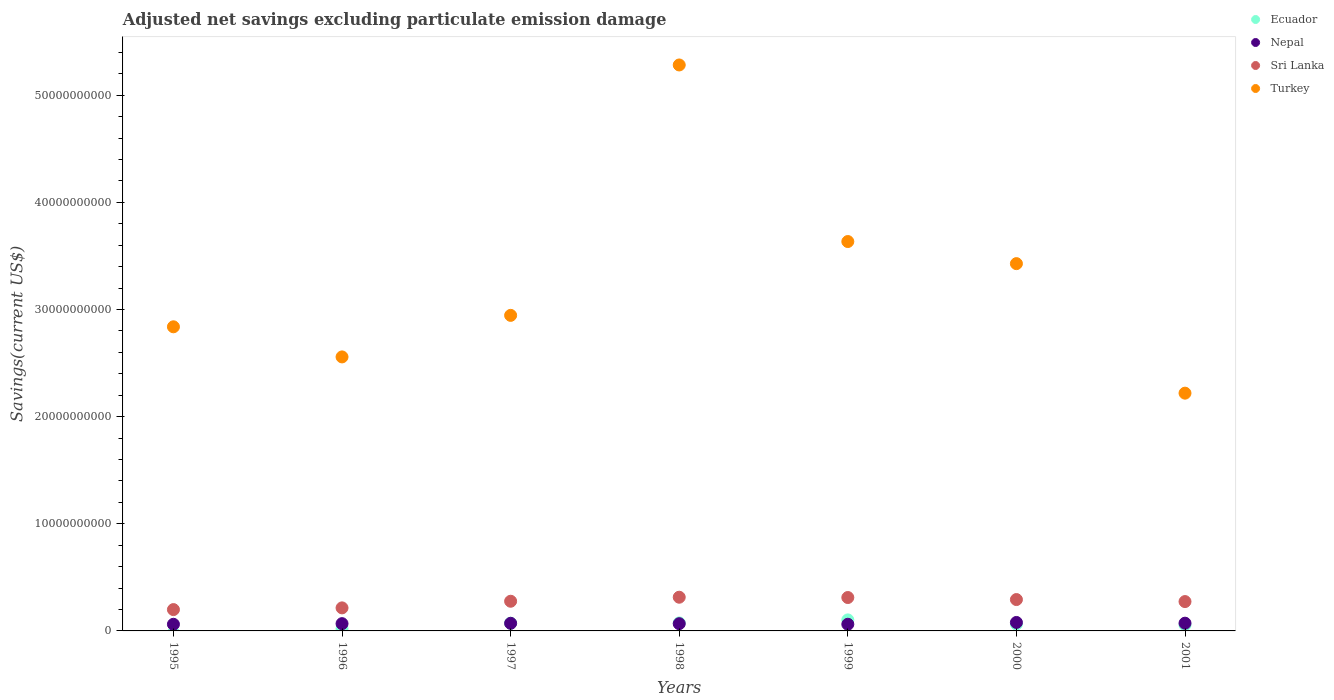How many different coloured dotlines are there?
Offer a terse response. 4. Is the number of dotlines equal to the number of legend labels?
Offer a very short reply. No. What is the adjusted net savings in Turkey in 2001?
Give a very brief answer. 2.22e+1. Across all years, what is the maximum adjusted net savings in Ecuador?
Offer a very short reply. 1.03e+09. What is the total adjusted net savings in Sri Lanka in the graph?
Give a very brief answer. 1.88e+1. What is the difference between the adjusted net savings in Nepal in 2000 and that in 2001?
Your answer should be very brief. 6.73e+07. What is the difference between the adjusted net savings in Nepal in 1997 and the adjusted net savings in Sri Lanka in 1995?
Your answer should be compact. -1.28e+09. What is the average adjusted net savings in Nepal per year?
Offer a very short reply. 6.89e+08. In the year 1996, what is the difference between the adjusted net savings in Turkey and adjusted net savings in Nepal?
Give a very brief answer. 2.49e+1. What is the ratio of the adjusted net savings in Nepal in 2000 to that in 2001?
Keep it short and to the point. 1.09. Is the adjusted net savings in Sri Lanka in 1997 less than that in 1998?
Provide a succinct answer. Yes. Is the difference between the adjusted net savings in Turkey in 1995 and 1997 greater than the difference between the adjusted net savings in Nepal in 1995 and 1997?
Provide a succinct answer. No. What is the difference between the highest and the second highest adjusted net savings in Sri Lanka?
Offer a very short reply. 2.79e+07. What is the difference between the highest and the lowest adjusted net savings in Ecuador?
Give a very brief answer. 1.03e+09. Is it the case that in every year, the sum of the adjusted net savings in Ecuador and adjusted net savings in Turkey  is greater than the sum of adjusted net savings in Sri Lanka and adjusted net savings in Nepal?
Give a very brief answer. Yes. Does the adjusted net savings in Turkey monotonically increase over the years?
Offer a very short reply. No. Is the adjusted net savings in Nepal strictly greater than the adjusted net savings in Turkey over the years?
Your answer should be very brief. No. How many years are there in the graph?
Keep it short and to the point. 7. What is the difference between two consecutive major ticks on the Y-axis?
Keep it short and to the point. 1.00e+1. Are the values on the major ticks of Y-axis written in scientific E-notation?
Your answer should be very brief. No. Does the graph contain any zero values?
Your answer should be very brief. Yes. Does the graph contain grids?
Offer a very short reply. No. What is the title of the graph?
Offer a terse response. Adjusted net savings excluding particulate emission damage. Does "Australia" appear as one of the legend labels in the graph?
Give a very brief answer. No. What is the label or title of the X-axis?
Offer a very short reply. Years. What is the label or title of the Y-axis?
Offer a terse response. Savings(current US$). What is the Savings(current US$) in Ecuador in 1995?
Give a very brief answer. 0. What is the Savings(current US$) in Nepal in 1995?
Provide a short and direct response. 6.20e+08. What is the Savings(current US$) in Sri Lanka in 1995?
Keep it short and to the point. 1.99e+09. What is the Savings(current US$) in Turkey in 1995?
Your answer should be very brief. 2.84e+1. What is the Savings(current US$) in Ecuador in 1996?
Your response must be concise. 1.97e+08. What is the Savings(current US$) of Nepal in 1996?
Offer a very short reply. 6.79e+08. What is the Savings(current US$) in Sri Lanka in 1996?
Your answer should be compact. 2.15e+09. What is the Savings(current US$) of Turkey in 1996?
Offer a very short reply. 2.56e+1. What is the Savings(current US$) in Ecuador in 1997?
Offer a terse response. 7.21e+08. What is the Savings(current US$) of Nepal in 1997?
Your answer should be very brief. 7.10e+08. What is the Savings(current US$) in Sri Lanka in 1997?
Make the answer very short. 2.77e+09. What is the Savings(current US$) in Turkey in 1997?
Your response must be concise. 2.95e+1. What is the Savings(current US$) of Ecuador in 1998?
Make the answer very short. 7.48e+08. What is the Savings(current US$) in Nepal in 1998?
Keep it short and to the point. 6.75e+08. What is the Savings(current US$) in Sri Lanka in 1998?
Offer a very short reply. 3.15e+09. What is the Savings(current US$) of Turkey in 1998?
Your answer should be very brief. 5.28e+1. What is the Savings(current US$) in Ecuador in 1999?
Ensure brevity in your answer.  1.03e+09. What is the Savings(current US$) in Nepal in 1999?
Make the answer very short. 6.23e+08. What is the Savings(current US$) in Sri Lanka in 1999?
Keep it short and to the point. 3.12e+09. What is the Savings(current US$) in Turkey in 1999?
Your answer should be very brief. 3.63e+1. What is the Savings(current US$) in Ecuador in 2000?
Offer a terse response. 6.41e+08. What is the Savings(current US$) of Nepal in 2000?
Keep it short and to the point. 7.90e+08. What is the Savings(current US$) of Sri Lanka in 2000?
Your response must be concise. 2.93e+09. What is the Savings(current US$) in Turkey in 2000?
Provide a succinct answer. 3.43e+1. What is the Savings(current US$) of Ecuador in 2001?
Your answer should be very brief. 5.61e+08. What is the Savings(current US$) of Nepal in 2001?
Offer a very short reply. 7.23e+08. What is the Savings(current US$) of Sri Lanka in 2001?
Make the answer very short. 2.74e+09. What is the Savings(current US$) of Turkey in 2001?
Provide a short and direct response. 2.22e+1. Across all years, what is the maximum Savings(current US$) in Ecuador?
Keep it short and to the point. 1.03e+09. Across all years, what is the maximum Savings(current US$) in Nepal?
Your answer should be compact. 7.90e+08. Across all years, what is the maximum Savings(current US$) of Sri Lanka?
Offer a very short reply. 3.15e+09. Across all years, what is the maximum Savings(current US$) in Turkey?
Provide a short and direct response. 5.28e+1. Across all years, what is the minimum Savings(current US$) in Nepal?
Keep it short and to the point. 6.20e+08. Across all years, what is the minimum Savings(current US$) in Sri Lanka?
Offer a very short reply. 1.99e+09. Across all years, what is the minimum Savings(current US$) of Turkey?
Your response must be concise. 2.22e+1. What is the total Savings(current US$) of Ecuador in the graph?
Offer a very short reply. 3.90e+09. What is the total Savings(current US$) of Nepal in the graph?
Provide a short and direct response. 4.82e+09. What is the total Savings(current US$) in Sri Lanka in the graph?
Provide a short and direct response. 1.88e+1. What is the total Savings(current US$) in Turkey in the graph?
Provide a short and direct response. 2.29e+11. What is the difference between the Savings(current US$) of Nepal in 1995 and that in 1996?
Offer a very short reply. -5.89e+07. What is the difference between the Savings(current US$) in Sri Lanka in 1995 and that in 1996?
Your response must be concise. -1.60e+08. What is the difference between the Savings(current US$) of Turkey in 1995 and that in 1996?
Provide a short and direct response. 2.81e+09. What is the difference between the Savings(current US$) in Nepal in 1995 and that in 1997?
Provide a succinct answer. -9.05e+07. What is the difference between the Savings(current US$) of Sri Lanka in 1995 and that in 1997?
Ensure brevity in your answer.  -7.79e+08. What is the difference between the Savings(current US$) of Turkey in 1995 and that in 1997?
Provide a succinct answer. -1.07e+09. What is the difference between the Savings(current US$) of Nepal in 1995 and that in 1998?
Provide a short and direct response. -5.53e+07. What is the difference between the Savings(current US$) of Sri Lanka in 1995 and that in 1998?
Your response must be concise. -1.15e+09. What is the difference between the Savings(current US$) in Turkey in 1995 and that in 1998?
Give a very brief answer. -2.44e+1. What is the difference between the Savings(current US$) in Nepal in 1995 and that in 1999?
Your answer should be very brief. -2.57e+06. What is the difference between the Savings(current US$) in Sri Lanka in 1995 and that in 1999?
Your answer should be compact. -1.13e+09. What is the difference between the Savings(current US$) in Turkey in 1995 and that in 1999?
Ensure brevity in your answer.  -7.96e+09. What is the difference between the Savings(current US$) in Nepal in 1995 and that in 2000?
Keep it short and to the point. -1.70e+08. What is the difference between the Savings(current US$) in Sri Lanka in 1995 and that in 2000?
Provide a succinct answer. -9.37e+08. What is the difference between the Savings(current US$) in Turkey in 1995 and that in 2000?
Offer a very short reply. -5.90e+09. What is the difference between the Savings(current US$) of Nepal in 1995 and that in 2001?
Provide a succinct answer. -1.03e+08. What is the difference between the Savings(current US$) in Sri Lanka in 1995 and that in 2001?
Your answer should be compact. -7.48e+08. What is the difference between the Savings(current US$) of Turkey in 1995 and that in 2001?
Make the answer very short. 6.19e+09. What is the difference between the Savings(current US$) in Ecuador in 1996 and that in 1997?
Your answer should be very brief. -5.25e+08. What is the difference between the Savings(current US$) in Nepal in 1996 and that in 1997?
Offer a terse response. -3.16e+07. What is the difference between the Savings(current US$) in Sri Lanka in 1996 and that in 1997?
Your answer should be very brief. -6.20e+08. What is the difference between the Savings(current US$) in Turkey in 1996 and that in 1997?
Your response must be concise. -3.88e+09. What is the difference between the Savings(current US$) in Ecuador in 1996 and that in 1998?
Your answer should be compact. -5.52e+08. What is the difference between the Savings(current US$) of Nepal in 1996 and that in 1998?
Offer a very short reply. 3.65e+06. What is the difference between the Savings(current US$) in Sri Lanka in 1996 and that in 1998?
Offer a terse response. -9.95e+08. What is the difference between the Savings(current US$) in Turkey in 1996 and that in 1998?
Your answer should be compact. -2.73e+1. What is the difference between the Savings(current US$) of Ecuador in 1996 and that in 1999?
Make the answer very short. -8.33e+08. What is the difference between the Savings(current US$) in Nepal in 1996 and that in 1999?
Ensure brevity in your answer.  5.64e+07. What is the difference between the Savings(current US$) in Sri Lanka in 1996 and that in 1999?
Ensure brevity in your answer.  -9.67e+08. What is the difference between the Savings(current US$) in Turkey in 1996 and that in 1999?
Provide a short and direct response. -1.08e+1. What is the difference between the Savings(current US$) of Ecuador in 1996 and that in 2000?
Offer a very short reply. -4.45e+08. What is the difference between the Savings(current US$) in Nepal in 1996 and that in 2000?
Ensure brevity in your answer.  -1.11e+08. What is the difference between the Savings(current US$) of Sri Lanka in 1996 and that in 2000?
Offer a terse response. -7.77e+08. What is the difference between the Savings(current US$) of Turkey in 1996 and that in 2000?
Your response must be concise. -8.71e+09. What is the difference between the Savings(current US$) in Ecuador in 1996 and that in 2001?
Offer a very short reply. -3.65e+08. What is the difference between the Savings(current US$) of Nepal in 1996 and that in 2001?
Make the answer very short. -4.42e+07. What is the difference between the Savings(current US$) of Sri Lanka in 1996 and that in 2001?
Make the answer very short. -5.89e+08. What is the difference between the Savings(current US$) in Turkey in 1996 and that in 2001?
Provide a succinct answer. 3.38e+09. What is the difference between the Savings(current US$) in Ecuador in 1997 and that in 1998?
Ensure brevity in your answer.  -2.72e+07. What is the difference between the Savings(current US$) in Nepal in 1997 and that in 1998?
Provide a short and direct response. 3.52e+07. What is the difference between the Savings(current US$) in Sri Lanka in 1997 and that in 1998?
Your answer should be compact. -3.75e+08. What is the difference between the Savings(current US$) in Turkey in 1997 and that in 1998?
Your response must be concise. -2.34e+1. What is the difference between the Savings(current US$) in Ecuador in 1997 and that in 1999?
Your answer should be very brief. -3.08e+08. What is the difference between the Savings(current US$) of Nepal in 1997 and that in 1999?
Your answer should be very brief. 8.79e+07. What is the difference between the Savings(current US$) in Sri Lanka in 1997 and that in 1999?
Provide a short and direct response. -3.47e+08. What is the difference between the Savings(current US$) in Turkey in 1997 and that in 1999?
Your answer should be very brief. -6.89e+09. What is the difference between the Savings(current US$) of Ecuador in 1997 and that in 2000?
Offer a terse response. 7.98e+07. What is the difference between the Savings(current US$) in Nepal in 1997 and that in 2000?
Offer a very short reply. -7.99e+07. What is the difference between the Savings(current US$) in Sri Lanka in 1997 and that in 2000?
Offer a terse response. -1.57e+08. What is the difference between the Savings(current US$) of Turkey in 1997 and that in 2000?
Provide a short and direct response. -4.83e+09. What is the difference between the Savings(current US$) in Ecuador in 1997 and that in 2001?
Your response must be concise. 1.60e+08. What is the difference between the Savings(current US$) in Nepal in 1997 and that in 2001?
Offer a terse response. -1.26e+07. What is the difference between the Savings(current US$) of Sri Lanka in 1997 and that in 2001?
Make the answer very short. 3.12e+07. What is the difference between the Savings(current US$) in Turkey in 1997 and that in 2001?
Keep it short and to the point. 7.26e+09. What is the difference between the Savings(current US$) of Ecuador in 1998 and that in 1999?
Provide a succinct answer. -2.81e+08. What is the difference between the Savings(current US$) in Nepal in 1998 and that in 1999?
Your answer should be very brief. 5.27e+07. What is the difference between the Savings(current US$) in Sri Lanka in 1998 and that in 1999?
Give a very brief answer. 2.79e+07. What is the difference between the Savings(current US$) of Turkey in 1998 and that in 1999?
Your response must be concise. 1.65e+1. What is the difference between the Savings(current US$) in Ecuador in 1998 and that in 2000?
Provide a succinct answer. 1.07e+08. What is the difference between the Savings(current US$) of Nepal in 1998 and that in 2000?
Offer a terse response. -1.15e+08. What is the difference between the Savings(current US$) in Sri Lanka in 1998 and that in 2000?
Ensure brevity in your answer.  2.18e+08. What is the difference between the Savings(current US$) in Turkey in 1998 and that in 2000?
Your answer should be compact. 1.85e+1. What is the difference between the Savings(current US$) in Ecuador in 1998 and that in 2001?
Offer a very short reply. 1.87e+08. What is the difference between the Savings(current US$) of Nepal in 1998 and that in 2001?
Provide a succinct answer. -4.78e+07. What is the difference between the Savings(current US$) in Sri Lanka in 1998 and that in 2001?
Provide a short and direct response. 4.06e+08. What is the difference between the Savings(current US$) of Turkey in 1998 and that in 2001?
Give a very brief answer. 3.06e+1. What is the difference between the Savings(current US$) of Ecuador in 1999 and that in 2000?
Make the answer very short. 3.88e+08. What is the difference between the Savings(current US$) of Nepal in 1999 and that in 2000?
Keep it short and to the point. -1.68e+08. What is the difference between the Savings(current US$) of Sri Lanka in 1999 and that in 2000?
Your response must be concise. 1.90e+08. What is the difference between the Savings(current US$) in Turkey in 1999 and that in 2000?
Offer a very short reply. 2.06e+09. What is the difference between the Savings(current US$) in Ecuador in 1999 and that in 2001?
Provide a short and direct response. 4.68e+08. What is the difference between the Savings(current US$) in Nepal in 1999 and that in 2001?
Your answer should be compact. -1.01e+08. What is the difference between the Savings(current US$) in Sri Lanka in 1999 and that in 2001?
Offer a very short reply. 3.78e+08. What is the difference between the Savings(current US$) in Turkey in 1999 and that in 2001?
Ensure brevity in your answer.  1.42e+1. What is the difference between the Savings(current US$) of Ecuador in 2000 and that in 2001?
Keep it short and to the point. 8.04e+07. What is the difference between the Savings(current US$) of Nepal in 2000 and that in 2001?
Keep it short and to the point. 6.73e+07. What is the difference between the Savings(current US$) of Sri Lanka in 2000 and that in 2001?
Offer a very short reply. 1.88e+08. What is the difference between the Savings(current US$) of Turkey in 2000 and that in 2001?
Provide a succinct answer. 1.21e+1. What is the difference between the Savings(current US$) in Nepal in 1995 and the Savings(current US$) in Sri Lanka in 1996?
Your response must be concise. -1.53e+09. What is the difference between the Savings(current US$) of Nepal in 1995 and the Savings(current US$) of Turkey in 1996?
Ensure brevity in your answer.  -2.50e+1. What is the difference between the Savings(current US$) in Sri Lanka in 1995 and the Savings(current US$) in Turkey in 1996?
Your answer should be compact. -2.36e+1. What is the difference between the Savings(current US$) of Nepal in 1995 and the Savings(current US$) of Sri Lanka in 1997?
Provide a short and direct response. -2.15e+09. What is the difference between the Savings(current US$) of Nepal in 1995 and the Savings(current US$) of Turkey in 1997?
Offer a terse response. -2.88e+1. What is the difference between the Savings(current US$) of Sri Lanka in 1995 and the Savings(current US$) of Turkey in 1997?
Make the answer very short. -2.75e+1. What is the difference between the Savings(current US$) in Nepal in 1995 and the Savings(current US$) in Sri Lanka in 1998?
Provide a succinct answer. -2.53e+09. What is the difference between the Savings(current US$) in Nepal in 1995 and the Savings(current US$) in Turkey in 1998?
Your answer should be very brief. -5.22e+1. What is the difference between the Savings(current US$) of Sri Lanka in 1995 and the Savings(current US$) of Turkey in 1998?
Make the answer very short. -5.08e+1. What is the difference between the Savings(current US$) of Nepal in 1995 and the Savings(current US$) of Sri Lanka in 1999?
Your response must be concise. -2.50e+09. What is the difference between the Savings(current US$) of Nepal in 1995 and the Savings(current US$) of Turkey in 1999?
Provide a succinct answer. -3.57e+1. What is the difference between the Savings(current US$) of Sri Lanka in 1995 and the Savings(current US$) of Turkey in 1999?
Provide a succinct answer. -3.44e+1. What is the difference between the Savings(current US$) in Nepal in 1995 and the Savings(current US$) in Sri Lanka in 2000?
Your answer should be very brief. -2.31e+09. What is the difference between the Savings(current US$) of Nepal in 1995 and the Savings(current US$) of Turkey in 2000?
Provide a short and direct response. -3.37e+1. What is the difference between the Savings(current US$) of Sri Lanka in 1995 and the Savings(current US$) of Turkey in 2000?
Offer a terse response. -3.23e+1. What is the difference between the Savings(current US$) in Nepal in 1995 and the Savings(current US$) in Sri Lanka in 2001?
Provide a short and direct response. -2.12e+09. What is the difference between the Savings(current US$) of Nepal in 1995 and the Savings(current US$) of Turkey in 2001?
Ensure brevity in your answer.  -2.16e+1. What is the difference between the Savings(current US$) in Sri Lanka in 1995 and the Savings(current US$) in Turkey in 2001?
Provide a succinct answer. -2.02e+1. What is the difference between the Savings(current US$) in Ecuador in 1996 and the Savings(current US$) in Nepal in 1997?
Make the answer very short. -5.14e+08. What is the difference between the Savings(current US$) of Ecuador in 1996 and the Savings(current US$) of Sri Lanka in 1997?
Make the answer very short. -2.57e+09. What is the difference between the Savings(current US$) of Ecuador in 1996 and the Savings(current US$) of Turkey in 1997?
Offer a very short reply. -2.93e+1. What is the difference between the Savings(current US$) of Nepal in 1996 and the Savings(current US$) of Sri Lanka in 1997?
Make the answer very short. -2.09e+09. What is the difference between the Savings(current US$) of Nepal in 1996 and the Savings(current US$) of Turkey in 1997?
Your response must be concise. -2.88e+1. What is the difference between the Savings(current US$) in Sri Lanka in 1996 and the Savings(current US$) in Turkey in 1997?
Give a very brief answer. -2.73e+1. What is the difference between the Savings(current US$) in Ecuador in 1996 and the Savings(current US$) in Nepal in 1998?
Provide a succinct answer. -4.79e+08. What is the difference between the Savings(current US$) of Ecuador in 1996 and the Savings(current US$) of Sri Lanka in 1998?
Make the answer very short. -2.95e+09. What is the difference between the Savings(current US$) in Ecuador in 1996 and the Savings(current US$) in Turkey in 1998?
Provide a succinct answer. -5.26e+1. What is the difference between the Savings(current US$) of Nepal in 1996 and the Savings(current US$) of Sri Lanka in 1998?
Provide a short and direct response. -2.47e+09. What is the difference between the Savings(current US$) in Nepal in 1996 and the Savings(current US$) in Turkey in 1998?
Give a very brief answer. -5.21e+1. What is the difference between the Savings(current US$) in Sri Lanka in 1996 and the Savings(current US$) in Turkey in 1998?
Give a very brief answer. -5.07e+1. What is the difference between the Savings(current US$) of Ecuador in 1996 and the Savings(current US$) of Nepal in 1999?
Offer a very short reply. -4.26e+08. What is the difference between the Savings(current US$) in Ecuador in 1996 and the Savings(current US$) in Sri Lanka in 1999?
Your answer should be very brief. -2.92e+09. What is the difference between the Savings(current US$) of Ecuador in 1996 and the Savings(current US$) of Turkey in 1999?
Provide a succinct answer. -3.61e+1. What is the difference between the Savings(current US$) in Nepal in 1996 and the Savings(current US$) in Sri Lanka in 1999?
Give a very brief answer. -2.44e+09. What is the difference between the Savings(current US$) of Nepal in 1996 and the Savings(current US$) of Turkey in 1999?
Keep it short and to the point. -3.57e+1. What is the difference between the Savings(current US$) in Sri Lanka in 1996 and the Savings(current US$) in Turkey in 1999?
Offer a terse response. -3.42e+1. What is the difference between the Savings(current US$) in Ecuador in 1996 and the Savings(current US$) in Nepal in 2000?
Keep it short and to the point. -5.94e+08. What is the difference between the Savings(current US$) in Ecuador in 1996 and the Savings(current US$) in Sri Lanka in 2000?
Provide a succinct answer. -2.73e+09. What is the difference between the Savings(current US$) of Ecuador in 1996 and the Savings(current US$) of Turkey in 2000?
Your answer should be compact. -3.41e+1. What is the difference between the Savings(current US$) of Nepal in 1996 and the Savings(current US$) of Sri Lanka in 2000?
Your response must be concise. -2.25e+09. What is the difference between the Savings(current US$) in Nepal in 1996 and the Savings(current US$) in Turkey in 2000?
Offer a very short reply. -3.36e+1. What is the difference between the Savings(current US$) in Sri Lanka in 1996 and the Savings(current US$) in Turkey in 2000?
Ensure brevity in your answer.  -3.21e+1. What is the difference between the Savings(current US$) of Ecuador in 1996 and the Savings(current US$) of Nepal in 2001?
Provide a short and direct response. -5.27e+08. What is the difference between the Savings(current US$) of Ecuador in 1996 and the Savings(current US$) of Sri Lanka in 2001?
Provide a short and direct response. -2.54e+09. What is the difference between the Savings(current US$) of Ecuador in 1996 and the Savings(current US$) of Turkey in 2001?
Provide a short and direct response. -2.20e+1. What is the difference between the Savings(current US$) in Nepal in 1996 and the Savings(current US$) in Sri Lanka in 2001?
Keep it short and to the point. -2.06e+09. What is the difference between the Savings(current US$) of Nepal in 1996 and the Savings(current US$) of Turkey in 2001?
Your response must be concise. -2.15e+1. What is the difference between the Savings(current US$) in Sri Lanka in 1996 and the Savings(current US$) in Turkey in 2001?
Provide a succinct answer. -2.00e+1. What is the difference between the Savings(current US$) of Ecuador in 1997 and the Savings(current US$) of Nepal in 1998?
Your answer should be compact. 4.60e+07. What is the difference between the Savings(current US$) in Ecuador in 1997 and the Savings(current US$) in Sri Lanka in 1998?
Your answer should be compact. -2.42e+09. What is the difference between the Savings(current US$) of Ecuador in 1997 and the Savings(current US$) of Turkey in 1998?
Provide a short and direct response. -5.21e+1. What is the difference between the Savings(current US$) of Nepal in 1997 and the Savings(current US$) of Sri Lanka in 1998?
Keep it short and to the point. -2.44e+09. What is the difference between the Savings(current US$) in Nepal in 1997 and the Savings(current US$) in Turkey in 1998?
Give a very brief answer. -5.21e+1. What is the difference between the Savings(current US$) in Sri Lanka in 1997 and the Savings(current US$) in Turkey in 1998?
Your answer should be compact. -5.01e+1. What is the difference between the Savings(current US$) of Ecuador in 1997 and the Savings(current US$) of Nepal in 1999?
Keep it short and to the point. 9.87e+07. What is the difference between the Savings(current US$) in Ecuador in 1997 and the Savings(current US$) in Sri Lanka in 1999?
Offer a very short reply. -2.40e+09. What is the difference between the Savings(current US$) in Ecuador in 1997 and the Savings(current US$) in Turkey in 1999?
Offer a terse response. -3.56e+1. What is the difference between the Savings(current US$) in Nepal in 1997 and the Savings(current US$) in Sri Lanka in 1999?
Offer a very short reply. -2.41e+09. What is the difference between the Savings(current US$) in Nepal in 1997 and the Savings(current US$) in Turkey in 1999?
Offer a terse response. -3.56e+1. What is the difference between the Savings(current US$) in Sri Lanka in 1997 and the Savings(current US$) in Turkey in 1999?
Your answer should be compact. -3.36e+1. What is the difference between the Savings(current US$) of Ecuador in 1997 and the Savings(current US$) of Nepal in 2000?
Your answer should be compact. -6.91e+07. What is the difference between the Savings(current US$) of Ecuador in 1997 and the Savings(current US$) of Sri Lanka in 2000?
Offer a terse response. -2.21e+09. What is the difference between the Savings(current US$) of Ecuador in 1997 and the Savings(current US$) of Turkey in 2000?
Provide a succinct answer. -3.36e+1. What is the difference between the Savings(current US$) in Nepal in 1997 and the Savings(current US$) in Sri Lanka in 2000?
Ensure brevity in your answer.  -2.22e+09. What is the difference between the Savings(current US$) in Nepal in 1997 and the Savings(current US$) in Turkey in 2000?
Give a very brief answer. -3.36e+1. What is the difference between the Savings(current US$) of Sri Lanka in 1997 and the Savings(current US$) of Turkey in 2000?
Your response must be concise. -3.15e+1. What is the difference between the Savings(current US$) of Ecuador in 1997 and the Savings(current US$) of Nepal in 2001?
Your answer should be very brief. -1.79e+06. What is the difference between the Savings(current US$) in Ecuador in 1997 and the Savings(current US$) in Sri Lanka in 2001?
Provide a succinct answer. -2.02e+09. What is the difference between the Savings(current US$) in Ecuador in 1997 and the Savings(current US$) in Turkey in 2001?
Offer a very short reply. -2.15e+1. What is the difference between the Savings(current US$) of Nepal in 1997 and the Savings(current US$) of Sri Lanka in 2001?
Make the answer very short. -2.03e+09. What is the difference between the Savings(current US$) of Nepal in 1997 and the Savings(current US$) of Turkey in 2001?
Provide a short and direct response. -2.15e+1. What is the difference between the Savings(current US$) in Sri Lanka in 1997 and the Savings(current US$) in Turkey in 2001?
Provide a succinct answer. -1.94e+1. What is the difference between the Savings(current US$) in Ecuador in 1998 and the Savings(current US$) in Nepal in 1999?
Make the answer very short. 1.26e+08. What is the difference between the Savings(current US$) in Ecuador in 1998 and the Savings(current US$) in Sri Lanka in 1999?
Give a very brief answer. -2.37e+09. What is the difference between the Savings(current US$) of Ecuador in 1998 and the Savings(current US$) of Turkey in 1999?
Provide a succinct answer. -3.56e+1. What is the difference between the Savings(current US$) in Nepal in 1998 and the Savings(current US$) in Sri Lanka in 1999?
Provide a succinct answer. -2.44e+09. What is the difference between the Savings(current US$) of Nepal in 1998 and the Savings(current US$) of Turkey in 1999?
Offer a terse response. -3.57e+1. What is the difference between the Savings(current US$) in Sri Lanka in 1998 and the Savings(current US$) in Turkey in 1999?
Make the answer very short. -3.32e+1. What is the difference between the Savings(current US$) of Ecuador in 1998 and the Savings(current US$) of Nepal in 2000?
Offer a terse response. -4.19e+07. What is the difference between the Savings(current US$) of Ecuador in 1998 and the Savings(current US$) of Sri Lanka in 2000?
Provide a short and direct response. -2.18e+09. What is the difference between the Savings(current US$) in Ecuador in 1998 and the Savings(current US$) in Turkey in 2000?
Keep it short and to the point. -3.35e+1. What is the difference between the Savings(current US$) of Nepal in 1998 and the Savings(current US$) of Sri Lanka in 2000?
Your response must be concise. -2.25e+09. What is the difference between the Savings(current US$) in Nepal in 1998 and the Savings(current US$) in Turkey in 2000?
Your answer should be compact. -3.36e+1. What is the difference between the Savings(current US$) in Sri Lanka in 1998 and the Savings(current US$) in Turkey in 2000?
Your answer should be compact. -3.11e+1. What is the difference between the Savings(current US$) of Ecuador in 1998 and the Savings(current US$) of Nepal in 2001?
Ensure brevity in your answer.  2.54e+07. What is the difference between the Savings(current US$) of Ecuador in 1998 and the Savings(current US$) of Sri Lanka in 2001?
Give a very brief answer. -1.99e+09. What is the difference between the Savings(current US$) in Ecuador in 1998 and the Savings(current US$) in Turkey in 2001?
Your answer should be compact. -2.14e+1. What is the difference between the Savings(current US$) of Nepal in 1998 and the Savings(current US$) of Sri Lanka in 2001?
Provide a short and direct response. -2.06e+09. What is the difference between the Savings(current US$) of Nepal in 1998 and the Savings(current US$) of Turkey in 2001?
Your response must be concise. -2.15e+1. What is the difference between the Savings(current US$) in Sri Lanka in 1998 and the Savings(current US$) in Turkey in 2001?
Your answer should be very brief. -1.90e+1. What is the difference between the Savings(current US$) of Ecuador in 1999 and the Savings(current US$) of Nepal in 2000?
Your response must be concise. 2.39e+08. What is the difference between the Savings(current US$) of Ecuador in 1999 and the Savings(current US$) of Sri Lanka in 2000?
Your answer should be very brief. -1.90e+09. What is the difference between the Savings(current US$) in Ecuador in 1999 and the Savings(current US$) in Turkey in 2000?
Your answer should be very brief. -3.33e+1. What is the difference between the Savings(current US$) in Nepal in 1999 and the Savings(current US$) in Sri Lanka in 2000?
Make the answer very short. -2.31e+09. What is the difference between the Savings(current US$) in Nepal in 1999 and the Savings(current US$) in Turkey in 2000?
Give a very brief answer. -3.37e+1. What is the difference between the Savings(current US$) in Sri Lanka in 1999 and the Savings(current US$) in Turkey in 2000?
Your response must be concise. -3.12e+1. What is the difference between the Savings(current US$) of Ecuador in 1999 and the Savings(current US$) of Nepal in 2001?
Make the answer very short. 3.06e+08. What is the difference between the Savings(current US$) in Ecuador in 1999 and the Savings(current US$) in Sri Lanka in 2001?
Your response must be concise. -1.71e+09. What is the difference between the Savings(current US$) of Ecuador in 1999 and the Savings(current US$) of Turkey in 2001?
Keep it short and to the point. -2.12e+1. What is the difference between the Savings(current US$) in Nepal in 1999 and the Savings(current US$) in Sri Lanka in 2001?
Provide a short and direct response. -2.12e+09. What is the difference between the Savings(current US$) in Nepal in 1999 and the Savings(current US$) in Turkey in 2001?
Give a very brief answer. -2.16e+1. What is the difference between the Savings(current US$) of Sri Lanka in 1999 and the Savings(current US$) of Turkey in 2001?
Give a very brief answer. -1.91e+1. What is the difference between the Savings(current US$) in Ecuador in 2000 and the Savings(current US$) in Nepal in 2001?
Provide a succinct answer. -8.16e+07. What is the difference between the Savings(current US$) in Ecuador in 2000 and the Savings(current US$) in Sri Lanka in 2001?
Your response must be concise. -2.10e+09. What is the difference between the Savings(current US$) in Ecuador in 2000 and the Savings(current US$) in Turkey in 2001?
Your answer should be very brief. -2.16e+1. What is the difference between the Savings(current US$) of Nepal in 2000 and the Savings(current US$) of Sri Lanka in 2001?
Offer a terse response. -1.95e+09. What is the difference between the Savings(current US$) in Nepal in 2000 and the Savings(current US$) in Turkey in 2001?
Give a very brief answer. -2.14e+1. What is the difference between the Savings(current US$) of Sri Lanka in 2000 and the Savings(current US$) of Turkey in 2001?
Give a very brief answer. -1.93e+1. What is the average Savings(current US$) of Ecuador per year?
Give a very brief answer. 5.57e+08. What is the average Savings(current US$) in Nepal per year?
Give a very brief answer. 6.89e+08. What is the average Savings(current US$) in Sri Lanka per year?
Keep it short and to the point. 2.69e+09. What is the average Savings(current US$) in Turkey per year?
Give a very brief answer. 3.27e+1. In the year 1995, what is the difference between the Savings(current US$) in Nepal and Savings(current US$) in Sri Lanka?
Provide a succinct answer. -1.37e+09. In the year 1995, what is the difference between the Savings(current US$) in Nepal and Savings(current US$) in Turkey?
Your response must be concise. -2.78e+1. In the year 1995, what is the difference between the Savings(current US$) in Sri Lanka and Savings(current US$) in Turkey?
Ensure brevity in your answer.  -2.64e+1. In the year 1996, what is the difference between the Savings(current US$) of Ecuador and Savings(current US$) of Nepal?
Ensure brevity in your answer.  -4.82e+08. In the year 1996, what is the difference between the Savings(current US$) in Ecuador and Savings(current US$) in Sri Lanka?
Provide a short and direct response. -1.95e+09. In the year 1996, what is the difference between the Savings(current US$) in Ecuador and Savings(current US$) in Turkey?
Make the answer very short. -2.54e+1. In the year 1996, what is the difference between the Savings(current US$) in Nepal and Savings(current US$) in Sri Lanka?
Offer a terse response. -1.47e+09. In the year 1996, what is the difference between the Savings(current US$) of Nepal and Savings(current US$) of Turkey?
Offer a very short reply. -2.49e+1. In the year 1996, what is the difference between the Savings(current US$) in Sri Lanka and Savings(current US$) in Turkey?
Provide a short and direct response. -2.34e+1. In the year 1997, what is the difference between the Savings(current US$) in Ecuador and Savings(current US$) in Nepal?
Your response must be concise. 1.08e+07. In the year 1997, what is the difference between the Savings(current US$) in Ecuador and Savings(current US$) in Sri Lanka?
Your response must be concise. -2.05e+09. In the year 1997, what is the difference between the Savings(current US$) of Ecuador and Savings(current US$) of Turkey?
Provide a short and direct response. -2.87e+1. In the year 1997, what is the difference between the Savings(current US$) in Nepal and Savings(current US$) in Sri Lanka?
Ensure brevity in your answer.  -2.06e+09. In the year 1997, what is the difference between the Savings(current US$) in Nepal and Savings(current US$) in Turkey?
Provide a short and direct response. -2.87e+1. In the year 1997, what is the difference between the Savings(current US$) of Sri Lanka and Savings(current US$) of Turkey?
Make the answer very short. -2.67e+1. In the year 1998, what is the difference between the Savings(current US$) of Ecuador and Savings(current US$) of Nepal?
Make the answer very short. 7.32e+07. In the year 1998, what is the difference between the Savings(current US$) of Ecuador and Savings(current US$) of Sri Lanka?
Offer a very short reply. -2.40e+09. In the year 1998, what is the difference between the Savings(current US$) of Ecuador and Savings(current US$) of Turkey?
Give a very brief answer. -5.21e+1. In the year 1998, what is the difference between the Savings(current US$) in Nepal and Savings(current US$) in Sri Lanka?
Keep it short and to the point. -2.47e+09. In the year 1998, what is the difference between the Savings(current US$) in Nepal and Savings(current US$) in Turkey?
Your answer should be compact. -5.22e+1. In the year 1998, what is the difference between the Savings(current US$) of Sri Lanka and Savings(current US$) of Turkey?
Provide a succinct answer. -4.97e+1. In the year 1999, what is the difference between the Savings(current US$) of Ecuador and Savings(current US$) of Nepal?
Keep it short and to the point. 4.07e+08. In the year 1999, what is the difference between the Savings(current US$) of Ecuador and Savings(current US$) of Sri Lanka?
Offer a terse response. -2.09e+09. In the year 1999, what is the difference between the Savings(current US$) of Ecuador and Savings(current US$) of Turkey?
Give a very brief answer. -3.53e+1. In the year 1999, what is the difference between the Savings(current US$) in Nepal and Savings(current US$) in Sri Lanka?
Your answer should be very brief. -2.50e+09. In the year 1999, what is the difference between the Savings(current US$) of Nepal and Savings(current US$) of Turkey?
Offer a very short reply. -3.57e+1. In the year 1999, what is the difference between the Savings(current US$) in Sri Lanka and Savings(current US$) in Turkey?
Offer a very short reply. -3.32e+1. In the year 2000, what is the difference between the Savings(current US$) in Ecuador and Savings(current US$) in Nepal?
Provide a short and direct response. -1.49e+08. In the year 2000, what is the difference between the Savings(current US$) of Ecuador and Savings(current US$) of Sri Lanka?
Keep it short and to the point. -2.29e+09. In the year 2000, what is the difference between the Savings(current US$) in Ecuador and Savings(current US$) in Turkey?
Make the answer very short. -3.36e+1. In the year 2000, what is the difference between the Savings(current US$) in Nepal and Savings(current US$) in Sri Lanka?
Offer a terse response. -2.14e+09. In the year 2000, what is the difference between the Savings(current US$) of Nepal and Savings(current US$) of Turkey?
Your answer should be compact. -3.35e+1. In the year 2000, what is the difference between the Savings(current US$) of Sri Lanka and Savings(current US$) of Turkey?
Make the answer very short. -3.14e+1. In the year 2001, what is the difference between the Savings(current US$) of Ecuador and Savings(current US$) of Nepal?
Provide a short and direct response. -1.62e+08. In the year 2001, what is the difference between the Savings(current US$) in Ecuador and Savings(current US$) in Sri Lanka?
Give a very brief answer. -2.18e+09. In the year 2001, what is the difference between the Savings(current US$) in Ecuador and Savings(current US$) in Turkey?
Make the answer very short. -2.16e+1. In the year 2001, what is the difference between the Savings(current US$) of Nepal and Savings(current US$) of Sri Lanka?
Your answer should be very brief. -2.02e+09. In the year 2001, what is the difference between the Savings(current US$) of Nepal and Savings(current US$) of Turkey?
Ensure brevity in your answer.  -2.15e+1. In the year 2001, what is the difference between the Savings(current US$) in Sri Lanka and Savings(current US$) in Turkey?
Provide a short and direct response. -1.95e+1. What is the ratio of the Savings(current US$) in Nepal in 1995 to that in 1996?
Keep it short and to the point. 0.91. What is the ratio of the Savings(current US$) of Sri Lanka in 1995 to that in 1996?
Keep it short and to the point. 0.93. What is the ratio of the Savings(current US$) of Turkey in 1995 to that in 1996?
Offer a very short reply. 1.11. What is the ratio of the Savings(current US$) in Nepal in 1995 to that in 1997?
Keep it short and to the point. 0.87. What is the ratio of the Savings(current US$) of Sri Lanka in 1995 to that in 1997?
Provide a succinct answer. 0.72. What is the ratio of the Savings(current US$) of Turkey in 1995 to that in 1997?
Ensure brevity in your answer.  0.96. What is the ratio of the Savings(current US$) of Nepal in 1995 to that in 1998?
Make the answer very short. 0.92. What is the ratio of the Savings(current US$) in Sri Lanka in 1995 to that in 1998?
Ensure brevity in your answer.  0.63. What is the ratio of the Savings(current US$) in Turkey in 1995 to that in 1998?
Ensure brevity in your answer.  0.54. What is the ratio of the Savings(current US$) of Nepal in 1995 to that in 1999?
Keep it short and to the point. 1. What is the ratio of the Savings(current US$) in Sri Lanka in 1995 to that in 1999?
Give a very brief answer. 0.64. What is the ratio of the Savings(current US$) of Turkey in 1995 to that in 1999?
Ensure brevity in your answer.  0.78. What is the ratio of the Savings(current US$) in Nepal in 1995 to that in 2000?
Your response must be concise. 0.78. What is the ratio of the Savings(current US$) of Sri Lanka in 1995 to that in 2000?
Your response must be concise. 0.68. What is the ratio of the Savings(current US$) of Turkey in 1995 to that in 2000?
Keep it short and to the point. 0.83. What is the ratio of the Savings(current US$) of Nepal in 1995 to that in 2001?
Provide a short and direct response. 0.86. What is the ratio of the Savings(current US$) of Sri Lanka in 1995 to that in 2001?
Your answer should be very brief. 0.73. What is the ratio of the Savings(current US$) in Turkey in 1995 to that in 2001?
Your answer should be compact. 1.28. What is the ratio of the Savings(current US$) in Ecuador in 1996 to that in 1997?
Your response must be concise. 0.27. What is the ratio of the Savings(current US$) of Nepal in 1996 to that in 1997?
Your answer should be compact. 0.96. What is the ratio of the Savings(current US$) in Sri Lanka in 1996 to that in 1997?
Make the answer very short. 0.78. What is the ratio of the Savings(current US$) of Turkey in 1996 to that in 1997?
Provide a succinct answer. 0.87. What is the ratio of the Savings(current US$) of Ecuador in 1996 to that in 1998?
Your answer should be very brief. 0.26. What is the ratio of the Savings(current US$) in Nepal in 1996 to that in 1998?
Offer a very short reply. 1.01. What is the ratio of the Savings(current US$) of Sri Lanka in 1996 to that in 1998?
Offer a very short reply. 0.68. What is the ratio of the Savings(current US$) of Turkey in 1996 to that in 1998?
Provide a short and direct response. 0.48. What is the ratio of the Savings(current US$) of Ecuador in 1996 to that in 1999?
Your response must be concise. 0.19. What is the ratio of the Savings(current US$) in Nepal in 1996 to that in 1999?
Your response must be concise. 1.09. What is the ratio of the Savings(current US$) of Sri Lanka in 1996 to that in 1999?
Make the answer very short. 0.69. What is the ratio of the Savings(current US$) in Turkey in 1996 to that in 1999?
Provide a succinct answer. 0.7. What is the ratio of the Savings(current US$) of Ecuador in 1996 to that in 2000?
Your answer should be compact. 0.31. What is the ratio of the Savings(current US$) of Nepal in 1996 to that in 2000?
Make the answer very short. 0.86. What is the ratio of the Savings(current US$) of Sri Lanka in 1996 to that in 2000?
Your response must be concise. 0.73. What is the ratio of the Savings(current US$) in Turkey in 1996 to that in 2000?
Offer a terse response. 0.75. What is the ratio of the Savings(current US$) in Ecuador in 1996 to that in 2001?
Offer a very short reply. 0.35. What is the ratio of the Savings(current US$) in Nepal in 1996 to that in 2001?
Give a very brief answer. 0.94. What is the ratio of the Savings(current US$) of Sri Lanka in 1996 to that in 2001?
Ensure brevity in your answer.  0.79. What is the ratio of the Savings(current US$) of Turkey in 1996 to that in 2001?
Your response must be concise. 1.15. What is the ratio of the Savings(current US$) in Ecuador in 1997 to that in 1998?
Your answer should be compact. 0.96. What is the ratio of the Savings(current US$) in Nepal in 1997 to that in 1998?
Offer a terse response. 1.05. What is the ratio of the Savings(current US$) of Sri Lanka in 1997 to that in 1998?
Ensure brevity in your answer.  0.88. What is the ratio of the Savings(current US$) of Turkey in 1997 to that in 1998?
Provide a short and direct response. 0.56. What is the ratio of the Savings(current US$) of Ecuador in 1997 to that in 1999?
Offer a terse response. 0.7. What is the ratio of the Savings(current US$) in Nepal in 1997 to that in 1999?
Make the answer very short. 1.14. What is the ratio of the Savings(current US$) in Sri Lanka in 1997 to that in 1999?
Your answer should be compact. 0.89. What is the ratio of the Savings(current US$) in Turkey in 1997 to that in 1999?
Your response must be concise. 0.81. What is the ratio of the Savings(current US$) in Ecuador in 1997 to that in 2000?
Provide a succinct answer. 1.12. What is the ratio of the Savings(current US$) in Nepal in 1997 to that in 2000?
Provide a short and direct response. 0.9. What is the ratio of the Savings(current US$) in Sri Lanka in 1997 to that in 2000?
Offer a very short reply. 0.95. What is the ratio of the Savings(current US$) in Turkey in 1997 to that in 2000?
Make the answer very short. 0.86. What is the ratio of the Savings(current US$) of Ecuador in 1997 to that in 2001?
Offer a very short reply. 1.29. What is the ratio of the Savings(current US$) of Nepal in 1997 to that in 2001?
Your response must be concise. 0.98. What is the ratio of the Savings(current US$) of Sri Lanka in 1997 to that in 2001?
Provide a succinct answer. 1.01. What is the ratio of the Savings(current US$) in Turkey in 1997 to that in 2001?
Ensure brevity in your answer.  1.33. What is the ratio of the Savings(current US$) of Ecuador in 1998 to that in 1999?
Make the answer very short. 0.73. What is the ratio of the Savings(current US$) in Nepal in 1998 to that in 1999?
Your answer should be compact. 1.08. What is the ratio of the Savings(current US$) of Sri Lanka in 1998 to that in 1999?
Your answer should be very brief. 1.01. What is the ratio of the Savings(current US$) in Turkey in 1998 to that in 1999?
Make the answer very short. 1.45. What is the ratio of the Savings(current US$) in Nepal in 1998 to that in 2000?
Ensure brevity in your answer.  0.85. What is the ratio of the Savings(current US$) of Sri Lanka in 1998 to that in 2000?
Your response must be concise. 1.07. What is the ratio of the Savings(current US$) of Turkey in 1998 to that in 2000?
Your answer should be very brief. 1.54. What is the ratio of the Savings(current US$) in Ecuador in 1998 to that in 2001?
Ensure brevity in your answer.  1.33. What is the ratio of the Savings(current US$) in Nepal in 1998 to that in 2001?
Make the answer very short. 0.93. What is the ratio of the Savings(current US$) of Sri Lanka in 1998 to that in 2001?
Make the answer very short. 1.15. What is the ratio of the Savings(current US$) of Turkey in 1998 to that in 2001?
Give a very brief answer. 2.38. What is the ratio of the Savings(current US$) of Ecuador in 1999 to that in 2000?
Make the answer very short. 1.6. What is the ratio of the Savings(current US$) in Nepal in 1999 to that in 2000?
Keep it short and to the point. 0.79. What is the ratio of the Savings(current US$) of Sri Lanka in 1999 to that in 2000?
Your response must be concise. 1.06. What is the ratio of the Savings(current US$) of Turkey in 1999 to that in 2000?
Your answer should be very brief. 1.06. What is the ratio of the Savings(current US$) of Ecuador in 1999 to that in 2001?
Ensure brevity in your answer.  1.83. What is the ratio of the Savings(current US$) in Nepal in 1999 to that in 2001?
Offer a terse response. 0.86. What is the ratio of the Savings(current US$) in Sri Lanka in 1999 to that in 2001?
Your response must be concise. 1.14. What is the ratio of the Savings(current US$) in Turkey in 1999 to that in 2001?
Your response must be concise. 1.64. What is the ratio of the Savings(current US$) in Ecuador in 2000 to that in 2001?
Keep it short and to the point. 1.14. What is the ratio of the Savings(current US$) of Nepal in 2000 to that in 2001?
Your answer should be very brief. 1.09. What is the ratio of the Savings(current US$) in Sri Lanka in 2000 to that in 2001?
Give a very brief answer. 1.07. What is the ratio of the Savings(current US$) of Turkey in 2000 to that in 2001?
Offer a terse response. 1.54. What is the difference between the highest and the second highest Savings(current US$) in Ecuador?
Your response must be concise. 2.81e+08. What is the difference between the highest and the second highest Savings(current US$) in Nepal?
Offer a terse response. 6.73e+07. What is the difference between the highest and the second highest Savings(current US$) in Sri Lanka?
Make the answer very short. 2.79e+07. What is the difference between the highest and the second highest Savings(current US$) in Turkey?
Give a very brief answer. 1.65e+1. What is the difference between the highest and the lowest Savings(current US$) of Ecuador?
Provide a succinct answer. 1.03e+09. What is the difference between the highest and the lowest Savings(current US$) of Nepal?
Ensure brevity in your answer.  1.70e+08. What is the difference between the highest and the lowest Savings(current US$) of Sri Lanka?
Your answer should be very brief. 1.15e+09. What is the difference between the highest and the lowest Savings(current US$) in Turkey?
Provide a succinct answer. 3.06e+1. 